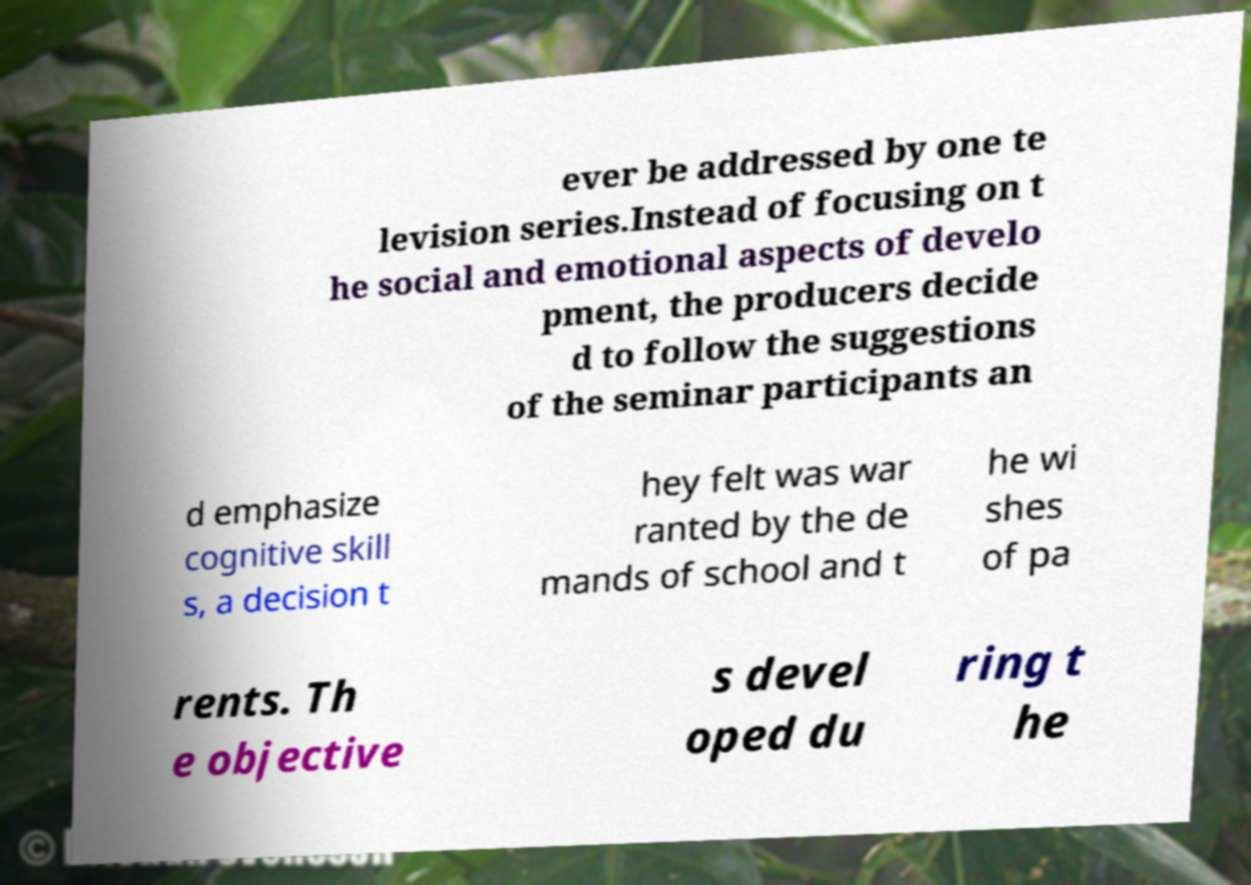Can you accurately transcribe the text from the provided image for me? ever be addressed by one te levision series.Instead of focusing on t he social and emotional aspects of develo pment, the producers decide d to follow the suggestions of the seminar participants an d emphasize cognitive skill s, a decision t hey felt was war ranted by the de mands of school and t he wi shes of pa rents. Th e objective s devel oped du ring t he 